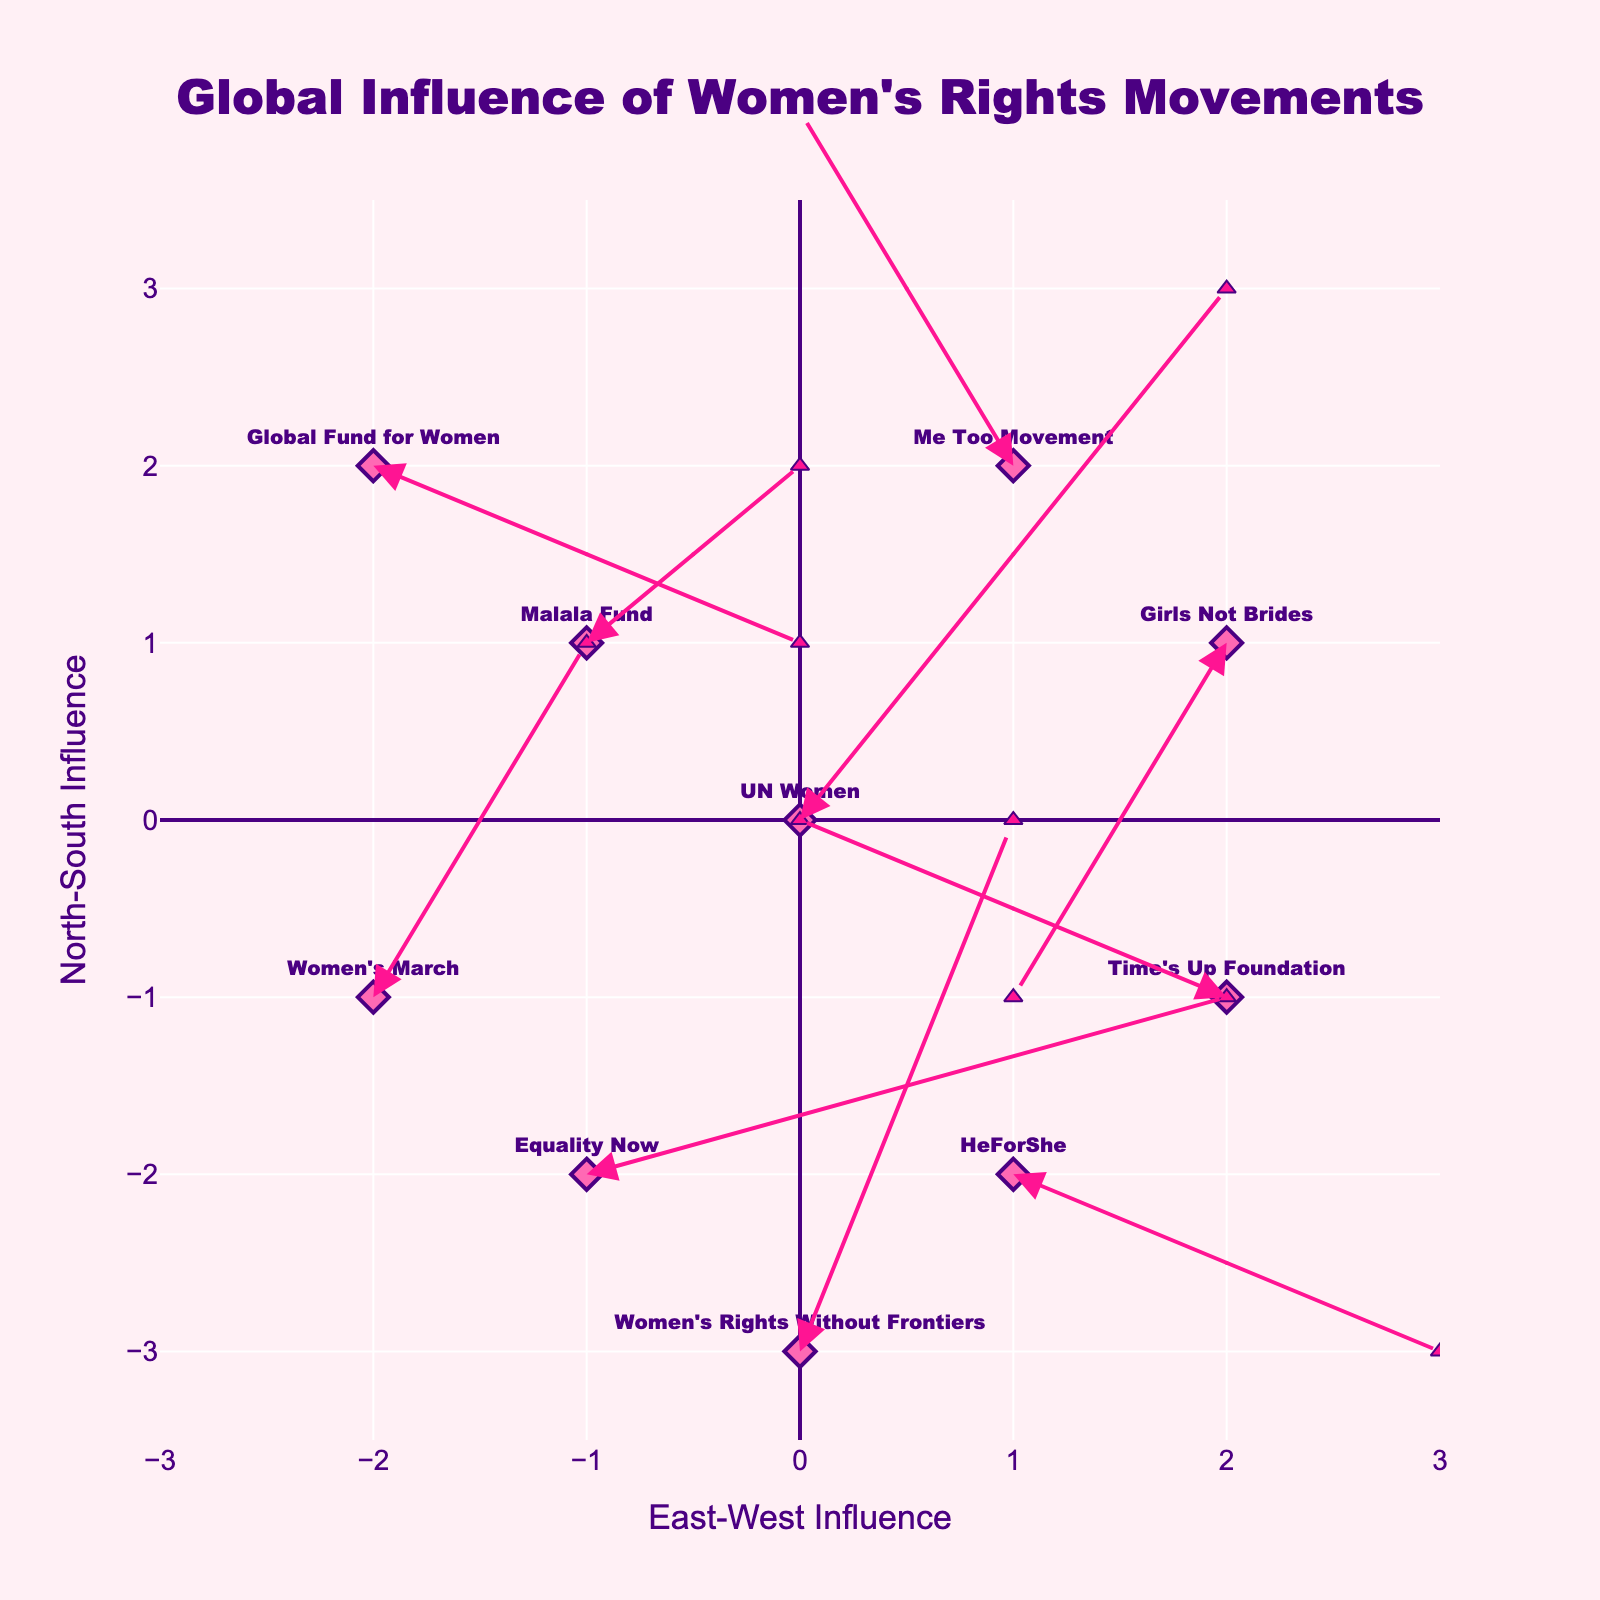What is the title of the figure? The title of the figure can usually be found at the top of the plot. It gives a high-level summary of what the plot is about. Here, the title is positioned centrally at the top.
Answer: Global Influence of Women's Rights Movements How many data points are represented in the plot? Count the number of labeled markers (representing organizations) displayed in the plot.
Answer: 10 Which organization shows the greatest northward influence? Look for the arrow that extends the furthest in the positive y-direction (North) from its starting point.
Answer: UN Women What is the eastward influence of the HeForShe organization? Locate the HeForShe label and check the direction and length of the arrow along the x-axis starting from this point, noting the positive or negative direction.
Answer: 2 Which organization has an arrow pointing southeast? Look for an arrow that has both a positive x-direction (east) and a negative y-direction (south) from the starting point.
Answer: Equality Now What is the average northward influence of all organizations? Sum the y components (v) of all vectors and divide by the total number of organizations (10). The v values are 3, 2, 1, 1, 2, -1, 1, -2, -1, 3, so the sum is 9. The average is 9/10.
Answer: 0.9 Which organization experiences both eastward and southward influences? Look for the arrow that has a positive x-component (east) and a negative y-component (south) from its starting point.
Answer: HeForShe Between the Malala Fund and Girls Not Brides, which has a greater total influence? Calculate the magnitude of the vectors for both organizations and compare. The formula for magnitude is sqrt(u^2 + v^2). For Malala Fund, it's sqrt(1^2 + 1^2)=sqrt(2). For Girls Not Brides, it's sqrt((-1)^2 + (-2)^2)=sqrt(5).
Answer: Girls Not Brides How many arrows extend in a western direction? Count the arrows that have a negative x-component (u) from their starting points. The relevant values are for Me Too Movement, Time's Up Foundation, and Girls Not Brides.
Answer: 3 Which organization has the longest vector influence, and what is its magnitude? Calculate the magnitudes of all vectors and identify the largest. The lengths are sqrt(2^2 + 3^2), sqrt((-1)^2 + 2^2), sqrt(1^2 + 1^2), sqrt((-2)^2 + 1^2), sqrt(1^2 + 2^2), sqrt(2^2 + (-1)^2), sqrt(3^2 + 1^2), sqrt((-1)^2 + (-2)^2), sqrt(2^2 + (-1)^2), sqrt(1^2 + 3^2). The largest magnitude is sqrt(2^2 + 3^2) = sqrt(13).
Answer: UN Women, sqrt(13) 